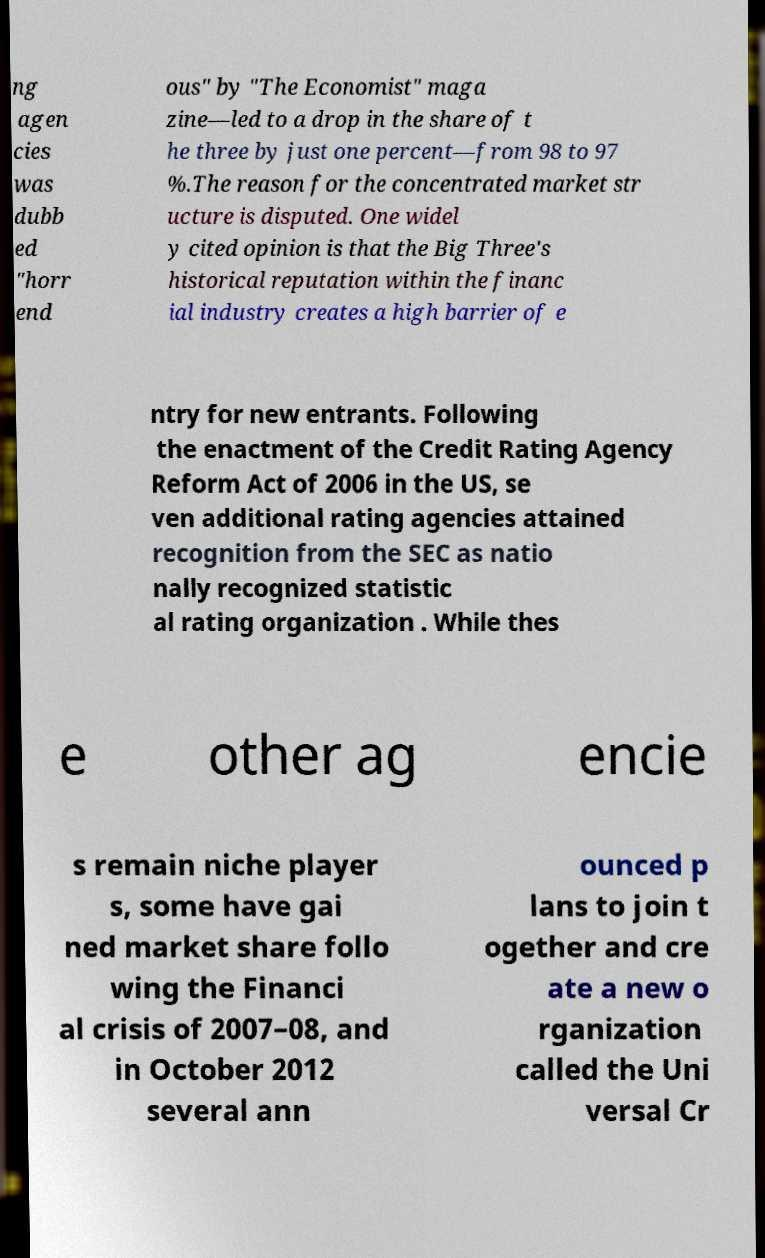I need the written content from this picture converted into text. Can you do that? ng agen cies was dubb ed "horr end ous" by "The Economist" maga zine—led to a drop in the share of t he three by just one percent—from 98 to 97 %.The reason for the concentrated market str ucture is disputed. One widel y cited opinion is that the Big Three's historical reputation within the financ ial industry creates a high barrier of e ntry for new entrants. Following the enactment of the Credit Rating Agency Reform Act of 2006 in the US, se ven additional rating agencies attained recognition from the SEC as natio nally recognized statistic al rating organization . While thes e other ag encie s remain niche player s, some have gai ned market share follo wing the Financi al crisis of 2007–08, and in October 2012 several ann ounced p lans to join t ogether and cre ate a new o rganization called the Uni versal Cr 